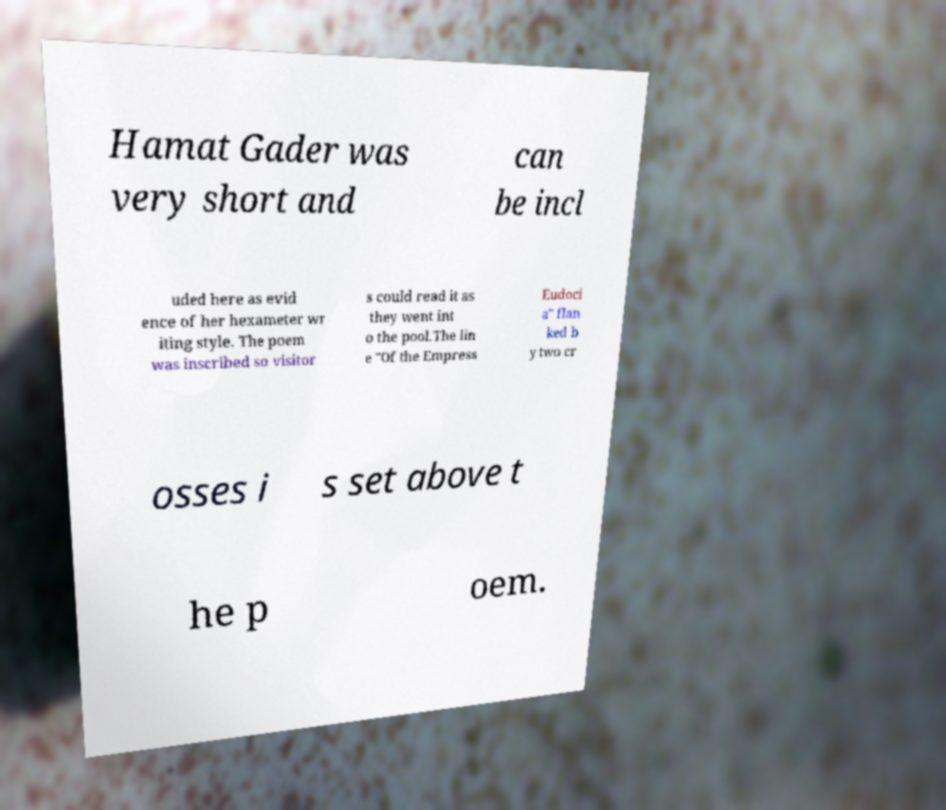Please identify and transcribe the text found in this image. Hamat Gader was very short and can be incl uded here as evid ence of her hexameter wr iting style. The poem was inscribed so visitor s could read it as they went int o the pool.The lin e "Of the Empress Eudoci a" flan ked b y two cr osses i s set above t he p oem. 